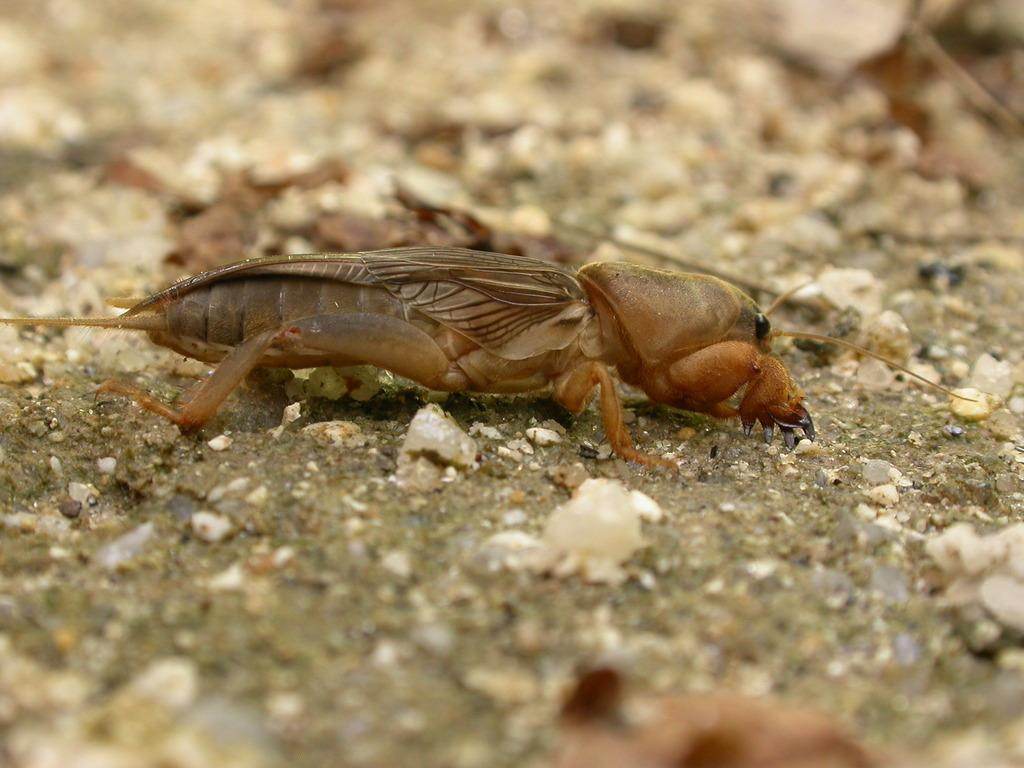What type of creature can be seen in the image? There is an insect in the image. Where is the insect located? The insect is on the sand. What type of arm is visible in the image? There is no arm present in the image; it only features an insect on the sand. Where is the nest of the insect in the image? There is no nest visible in the image; it only shows an insect on the sand. 